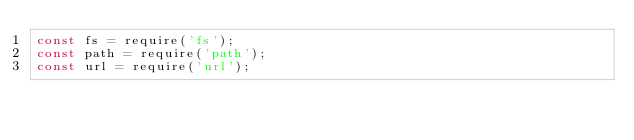<code> <loc_0><loc_0><loc_500><loc_500><_JavaScript_>const fs = require('fs');
const path = require('path');
const url = require('url');</code> 